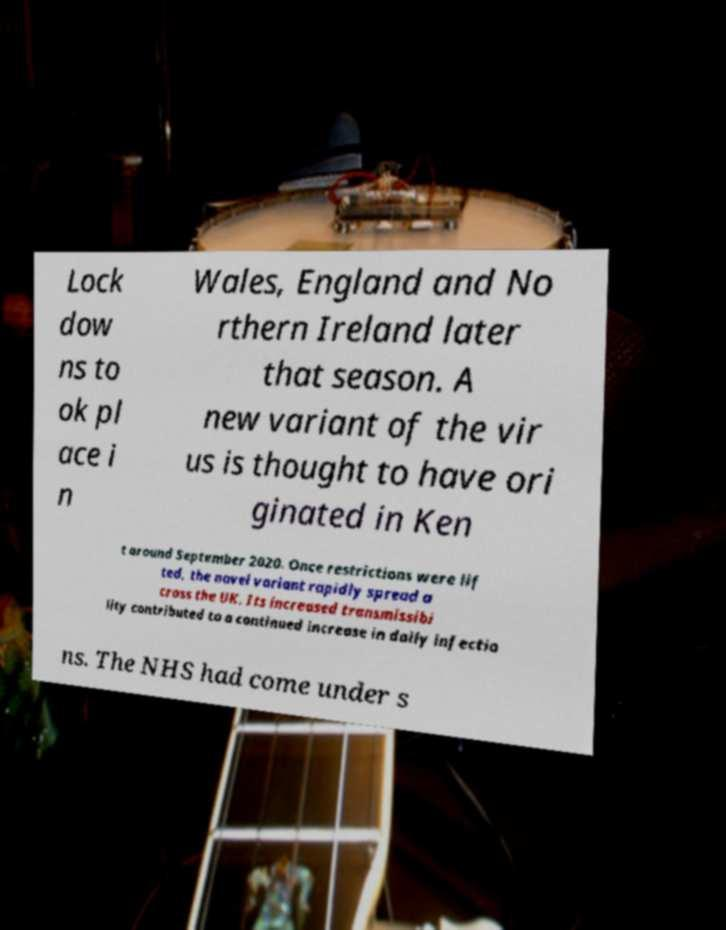Could you assist in decoding the text presented in this image and type it out clearly? Lock dow ns to ok pl ace i n Wales, England and No rthern Ireland later that season. A new variant of the vir us is thought to have ori ginated in Ken t around September 2020. Once restrictions were lif ted, the novel variant rapidly spread a cross the UK. Its increased transmissibi lity contributed to a continued increase in daily infectio ns. The NHS had come under s 